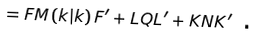Convert formula to latex. <formula><loc_0><loc_0><loc_500><loc_500>= F M \left ( k | k \right ) F ^ { \prime } + L Q L ^ { \prime } + K N K ^ { \prime } \text { .}</formula> 